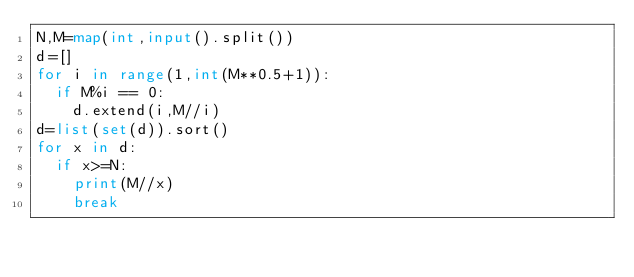<code> <loc_0><loc_0><loc_500><loc_500><_Python_>N,M=map(int,input().split())
d=[]
for i in range(1,int(M**0.5+1)):
  if M%i == 0:
    d.extend(i,M//i)
d=list(set(d)).sort()
for x in d:
  if x>=N:
    print(M//x)
    break
</code> 